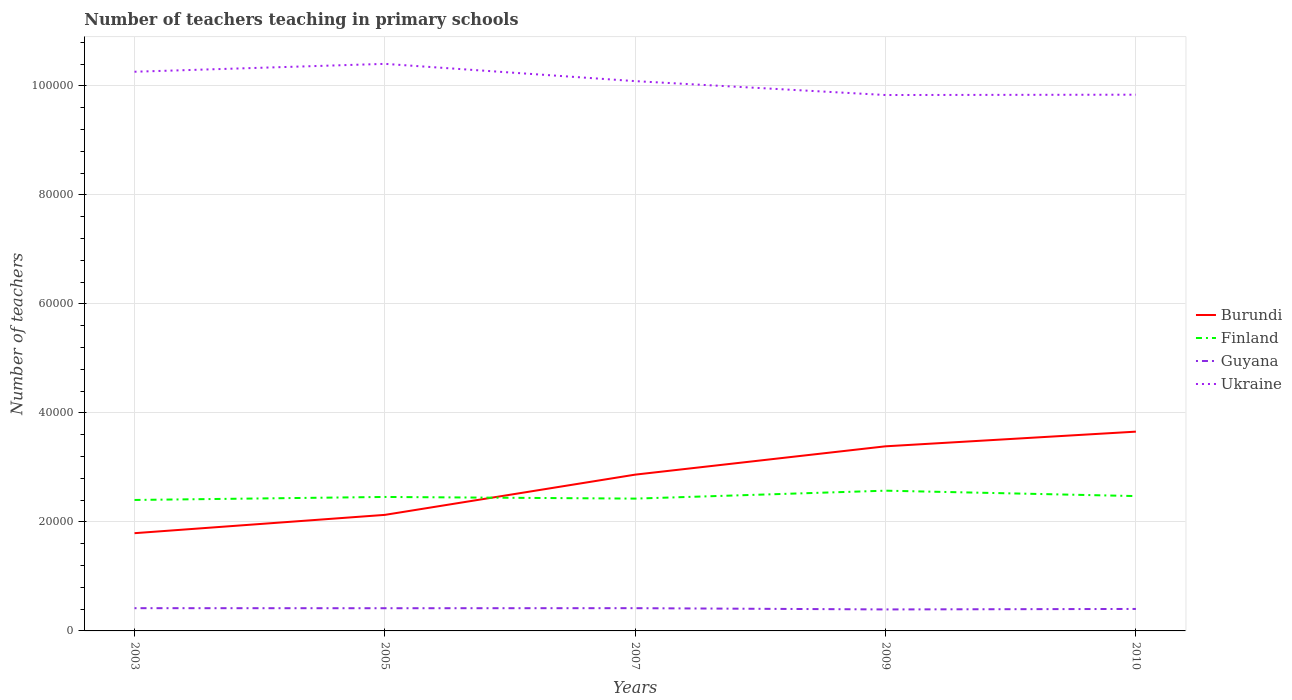How many different coloured lines are there?
Your answer should be compact. 4. Across all years, what is the maximum number of teachers teaching in primary schools in Ukraine?
Your answer should be compact. 9.83e+04. What is the total number of teachers teaching in primary schools in Burundi in the graph?
Ensure brevity in your answer.  -7382. What is the difference between the highest and the second highest number of teachers teaching in primary schools in Finland?
Offer a terse response. 1704. What is the difference between the highest and the lowest number of teachers teaching in primary schools in Burundi?
Make the answer very short. 3. Is the number of teachers teaching in primary schools in Burundi strictly greater than the number of teachers teaching in primary schools in Guyana over the years?
Give a very brief answer. No. How many years are there in the graph?
Provide a succinct answer. 5. What is the difference between two consecutive major ticks on the Y-axis?
Offer a very short reply. 2.00e+04. Are the values on the major ticks of Y-axis written in scientific E-notation?
Offer a very short reply. No. Does the graph contain grids?
Your response must be concise. Yes. How are the legend labels stacked?
Make the answer very short. Vertical. What is the title of the graph?
Offer a very short reply. Number of teachers teaching in primary schools. Does "Sri Lanka" appear as one of the legend labels in the graph?
Your answer should be very brief. No. What is the label or title of the Y-axis?
Provide a short and direct response. Number of teachers. What is the Number of teachers in Burundi in 2003?
Your answer should be compact. 1.79e+04. What is the Number of teachers of Finland in 2003?
Ensure brevity in your answer.  2.40e+04. What is the Number of teachers in Guyana in 2003?
Ensure brevity in your answer.  4174. What is the Number of teachers of Ukraine in 2003?
Make the answer very short. 1.03e+05. What is the Number of teachers of Burundi in 2005?
Ensure brevity in your answer.  2.13e+04. What is the Number of teachers of Finland in 2005?
Ensure brevity in your answer.  2.46e+04. What is the Number of teachers of Guyana in 2005?
Offer a very short reply. 4164. What is the Number of teachers in Ukraine in 2005?
Provide a succinct answer. 1.04e+05. What is the Number of teachers in Burundi in 2007?
Offer a terse response. 2.87e+04. What is the Number of teachers of Finland in 2007?
Make the answer very short. 2.43e+04. What is the Number of teachers in Guyana in 2007?
Your answer should be compact. 4173. What is the Number of teachers of Ukraine in 2007?
Your answer should be compact. 1.01e+05. What is the Number of teachers in Burundi in 2009?
Make the answer very short. 3.39e+04. What is the Number of teachers of Finland in 2009?
Your answer should be compact. 2.57e+04. What is the Number of teachers of Guyana in 2009?
Offer a terse response. 3942. What is the Number of teachers in Ukraine in 2009?
Keep it short and to the point. 9.83e+04. What is the Number of teachers of Burundi in 2010?
Your response must be concise. 3.66e+04. What is the Number of teachers of Finland in 2010?
Your answer should be compact. 2.47e+04. What is the Number of teachers in Guyana in 2010?
Offer a very short reply. 4031. What is the Number of teachers in Ukraine in 2010?
Your response must be concise. 9.84e+04. Across all years, what is the maximum Number of teachers in Burundi?
Give a very brief answer. 3.66e+04. Across all years, what is the maximum Number of teachers of Finland?
Keep it short and to the point. 2.57e+04. Across all years, what is the maximum Number of teachers of Guyana?
Make the answer very short. 4174. Across all years, what is the maximum Number of teachers of Ukraine?
Ensure brevity in your answer.  1.04e+05. Across all years, what is the minimum Number of teachers of Burundi?
Provide a short and direct response. 1.79e+04. Across all years, what is the minimum Number of teachers of Finland?
Offer a very short reply. 2.40e+04. Across all years, what is the minimum Number of teachers of Guyana?
Make the answer very short. 3942. Across all years, what is the minimum Number of teachers in Ukraine?
Ensure brevity in your answer.  9.83e+04. What is the total Number of teachers of Burundi in the graph?
Offer a very short reply. 1.38e+05. What is the total Number of teachers in Finland in the graph?
Your answer should be compact. 1.23e+05. What is the total Number of teachers in Guyana in the graph?
Give a very brief answer. 2.05e+04. What is the total Number of teachers of Ukraine in the graph?
Offer a very short reply. 5.04e+05. What is the difference between the Number of teachers of Burundi in 2003 and that in 2005?
Keep it short and to the point. -3358. What is the difference between the Number of teachers of Finland in 2003 and that in 2005?
Keep it short and to the point. -553. What is the difference between the Number of teachers in Guyana in 2003 and that in 2005?
Provide a succinct answer. 10. What is the difference between the Number of teachers of Ukraine in 2003 and that in 2005?
Your answer should be very brief. -1447. What is the difference between the Number of teachers of Burundi in 2003 and that in 2007?
Ensure brevity in your answer.  -1.07e+04. What is the difference between the Number of teachers in Finland in 2003 and that in 2007?
Your response must be concise. -248. What is the difference between the Number of teachers of Guyana in 2003 and that in 2007?
Keep it short and to the point. 1. What is the difference between the Number of teachers of Ukraine in 2003 and that in 2007?
Offer a terse response. 1722. What is the difference between the Number of teachers of Burundi in 2003 and that in 2009?
Your answer should be compact. -1.59e+04. What is the difference between the Number of teachers in Finland in 2003 and that in 2009?
Provide a succinct answer. -1704. What is the difference between the Number of teachers in Guyana in 2003 and that in 2009?
Offer a terse response. 232. What is the difference between the Number of teachers in Ukraine in 2003 and that in 2009?
Your response must be concise. 4271. What is the difference between the Number of teachers in Burundi in 2003 and that in 2010?
Provide a succinct answer. -1.86e+04. What is the difference between the Number of teachers in Finland in 2003 and that in 2010?
Provide a succinct answer. -712. What is the difference between the Number of teachers of Guyana in 2003 and that in 2010?
Your response must be concise. 143. What is the difference between the Number of teachers of Ukraine in 2003 and that in 2010?
Your answer should be compact. 4210. What is the difference between the Number of teachers of Burundi in 2005 and that in 2007?
Keep it short and to the point. -7382. What is the difference between the Number of teachers in Finland in 2005 and that in 2007?
Keep it short and to the point. 305. What is the difference between the Number of teachers of Guyana in 2005 and that in 2007?
Your answer should be compact. -9. What is the difference between the Number of teachers in Ukraine in 2005 and that in 2007?
Your answer should be compact. 3169. What is the difference between the Number of teachers in Burundi in 2005 and that in 2009?
Your answer should be compact. -1.26e+04. What is the difference between the Number of teachers in Finland in 2005 and that in 2009?
Your answer should be very brief. -1151. What is the difference between the Number of teachers in Guyana in 2005 and that in 2009?
Keep it short and to the point. 222. What is the difference between the Number of teachers of Ukraine in 2005 and that in 2009?
Ensure brevity in your answer.  5718. What is the difference between the Number of teachers in Burundi in 2005 and that in 2010?
Provide a short and direct response. -1.53e+04. What is the difference between the Number of teachers of Finland in 2005 and that in 2010?
Provide a short and direct response. -159. What is the difference between the Number of teachers in Guyana in 2005 and that in 2010?
Offer a very short reply. 133. What is the difference between the Number of teachers of Ukraine in 2005 and that in 2010?
Provide a short and direct response. 5657. What is the difference between the Number of teachers in Burundi in 2007 and that in 2009?
Give a very brief answer. -5196. What is the difference between the Number of teachers in Finland in 2007 and that in 2009?
Make the answer very short. -1456. What is the difference between the Number of teachers in Guyana in 2007 and that in 2009?
Provide a short and direct response. 231. What is the difference between the Number of teachers of Ukraine in 2007 and that in 2009?
Your answer should be very brief. 2549. What is the difference between the Number of teachers in Burundi in 2007 and that in 2010?
Make the answer very short. -7886. What is the difference between the Number of teachers of Finland in 2007 and that in 2010?
Make the answer very short. -464. What is the difference between the Number of teachers in Guyana in 2007 and that in 2010?
Keep it short and to the point. 142. What is the difference between the Number of teachers of Ukraine in 2007 and that in 2010?
Ensure brevity in your answer.  2488. What is the difference between the Number of teachers in Burundi in 2009 and that in 2010?
Your answer should be compact. -2690. What is the difference between the Number of teachers of Finland in 2009 and that in 2010?
Your response must be concise. 992. What is the difference between the Number of teachers of Guyana in 2009 and that in 2010?
Your response must be concise. -89. What is the difference between the Number of teachers of Ukraine in 2009 and that in 2010?
Provide a short and direct response. -61. What is the difference between the Number of teachers in Burundi in 2003 and the Number of teachers in Finland in 2005?
Your answer should be very brief. -6646. What is the difference between the Number of teachers in Burundi in 2003 and the Number of teachers in Guyana in 2005?
Your answer should be compact. 1.38e+04. What is the difference between the Number of teachers of Burundi in 2003 and the Number of teachers of Ukraine in 2005?
Provide a short and direct response. -8.61e+04. What is the difference between the Number of teachers of Finland in 2003 and the Number of teachers of Guyana in 2005?
Offer a terse response. 1.99e+04. What is the difference between the Number of teachers of Finland in 2003 and the Number of teachers of Ukraine in 2005?
Provide a succinct answer. -8.00e+04. What is the difference between the Number of teachers of Guyana in 2003 and the Number of teachers of Ukraine in 2005?
Offer a very short reply. -9.99e+04. What is the difference between the Number of teachers of Burundi in 2003 and the Number of teachers of Finland in 2007?
Your answer should be compact. -6341. What is the difference between the Number of teachers of Burundi in 2003 and the Number of teachers of Guyana in 2007?
Give a very brief answer. 1.38e+04. What is the difference between the Number of teachers in Burundi in 2003 and the Number of teachers in Ukraine in 2007?
Provide a short and direct response. -8.29e+04. What is the difference between the Number of teachers of Finland in 2003 and the Number of teachers of Guyana in 2007?
Your response must be concise. 1.99e+04. What is the difference between the Number of teachers of Finland in 2003 and the Number of teachers of Ukraine in 2007?
Make the answer very short. -7.68e+04. What is the difference between the Number of teachers of Guyana in 2003 and the Number of teachers of Ukraine in 2007?
Your answer should be compact. -9.67e+04. What is the difference between the Number of teachers of Burundi in 2003 and the Number of teachers of Finland in 2009?
Your answer should be very brief. -7797. What is the difference between the Number of teachers in Burundi in 2003 and the Number of teachers in Guyana in 2009?
Your answer should be very brief. 1.40e+04. What is the difference between the Number of teachers in Burundi in 2003 and the Number of teachers in Ukraine in 2009?
Your answer should be very brief. -8.04e+04. What is the difference between the Number of teachers in Finland in 2003 and the Number of teachers in Guyana in 2009?
Give a very brief answer. 2.01e+04. What is the difference between the Number of teachers of Finland in 2003 and the Number of teachers of Ukraine in 2009?
Ensure brevity in your answer.  -7.43e+04. What is the difference between the Number of teachers of Guyana in 2003 and the Number of teachers of Ukraine in 2009?
Offer a very short reply. -9.41e+04. What is the difference between the Number of teachers of Burundi in 2003 and the Number of teachers of Finland in 2010?
Offer a terse response. -6805. What is the difference between the Number of teachers in Burundi in 2003 and the Number of teachers in Guyana in 2010?
Keep it short and to the point. 1.39e+04. What is the difference between the Number of teachers of Burundi in 2003 and the Number of teachers of Ukraine in 2010?
Provide a succinct answer. -8.04e+04. What is the difference between the Number of teachers in Finland in 2003 and the Number of teachers in Guyana in 2010?
Ensure brevity in your answer.  2.00e+04. What is the difference between the Number of teachers in Finland in 2003 and the Number of teachers in Ukraine in 2010?
Your answer should be compact. -7.43e+04. What is the difference between the Number of teachers of Guyana in 2003 and the Number of teachers of Ukraine in 2010?
Provide a succinct answer. -9.42e+04. What is the difference between the Number of teachers in Burundi in 2005 and the Number of teachers in Finland in 2007?
Offer a terse response. -2983. What is the difference between the Number of teachers in Burundi in 2005 and the Number of teachers in Guyana in 2007?
Provide a succinct answer. 1.71e+04. What is the difference between the Number of teachers in Burundi in 2005 and the Number of teachers in Ukraine in 2007?
Provide a short and direct response. -7.96e+04. What is the difference between the Number of teachers in Finland in 2005 and the Number of teachers in Guyana in 2007?
Give a very brief answer. 2.04e+04. What is the difference between the Number of teachers in Finland in 2005 and the Number of teachers in Ukraine in 2007?
Your response must be concise. -7.63e+04. What is the difference between the Number of teachers of Guyana in 2005 and the Number of teachers of Ukraine in 2007?
Your response must be concise. -9.67e+04. What is the difference between the Number of teachers in Burundi in 2005 and the Number of teachers in Finland in 2009?
Provide a short and direct response. -4439. What is the difference between the Number of teachers of Burundi in 2005 and the Number of teachers of Guyana in 2009?
Your response must be concise. 1.73e+04. What is the difference between the Number of teachers of Burundi in 2005 and the Number of teachers of Ukraine in 2009?
Your response must be concise. -7.70e+04. What is the difference between the Number of teachers in Finland in 2005 and the Number of teachers in Guyana in 2009?
Give a very brief answer. 2.06e+04. What is the difference between the Number of teachers in Finland in 2005 and the Number of teachers in Ukraine in 2009?
Give a very brief answer. -7.37e+04. What is the difference between the Number of teachers in Guyana in 2005 and the Number of teachers in Ukraine in 2009?
Your response must be concise. -9.41e+04. What is the difference between the Number of teachers in Burundi in 2005 and the Number of teachers in Finland in 2010?
Ensure brevity in your answer.  -3447. What is the difference between the Number of teachers in Burundi in 2005 and the Number of teachers in Guyana in 2010?
Ensure brevity in your answer.  1.73e+04. What is the difference between the Number of teachers of Burundi in 2005 and the Number of teachers of Ukraine in 2010?
Ensure brevity in your answer.  -7.71e+04. What is the difference between the Number of teachers in Finland in 2005 and the Number of teachers in Guyana in 2010?
Make the answer very short. 2.05e+04. What is the difference between the Number of teachers of Finland in 2005 and the Number of teachers of Ukraine in 2010?
Ensure brevity in your answer.  -7.38e+04. What is the difference between the Number of teachers in Guyana in 2005 and the Number of teachers in Ukraine in 2010?
Your answer should be compact. -9.42e+04. What is the difference between the Number of teachers of Burundi in 2007 and the Number of teachers of Finland in 2009?
Give a very brief answer. 2943. What is the difference between the Number of teachers in Burundi in 2007 and the Number of teachers in Guyana in 2009?
Make the answer very short. 2.47e+04. What is the difference between the Number of teachers in Burundi in 2007 and the Number of teachers in Ukraine in 2009?
Offer a terse response. -6.96e+04. What is the difference between the Number of teachers in Finland in 2007 and the Number of teachers in Guyana in 2009?
Offer a terse response. 2.03e+04. What is the difference between the Number of teachers in Finland in 2007 and the Number of teachers in Ukraine in 2009?
Offer a very short reply. -7.40e+04. What is the difference between the Number of teachers in Guyana in 2007 and the Number of teachers in Ukraine in 2009?
Offer a very short reply. -9.41e+04. What is the difference between the Number of teachers in Burundi in 2007 and the Number of teachers in Finland in 2010?
Give a very brief answer. 3935. What is the difference between the Number of teachers of Burundi in 2007 and the Number of teachers of Guyana in 2010?
Provide a short and direct response. 2.46e+04. What is the difference between the Number of teachers in Burundi in 2007 and the Number of teachers in Ukraine in 2010?
Make the answer very short. -6.97e+04. What is the difference between the Number of teachers in Finland in 2007 and the Number of teachers in Guyana in 2010?
Your answer should be compact. 2.02e+04. What is the difference between the Number of teachers in Finland in 2007 and the Number of teachers in Ukraine in 2010?
Keep it short and to the point. -7.41e+04. What is the difference between the Number of teachers in Guyana in 2007 and the Number of teachers in Ukraine in 2010?
Your response must be concise. -9.42e+04. What is the difference between the Number of teachers in Burundi in 2009 and the Number of teachers in Finland in 2010?
Your response must be concise. 9131. What is the difference between the Number of teachers in Burundi in 2009 and the Number of teachers in Guyana in 2010?
Your response must be concise. 2.98e+04. What is the difference between the Number of teachers of Burundi in 2009 and the Number of teachers of Ukraine in 2010?
Your answer should be compact. -6.45e+04. What is the difference between the Number of teachers in Finland in 2009 and the Number of teachers in Guyana in 2010?
Offer a terse response. 2.17e+04. What is the difference between the Number of teachers of Finland in 2009 and the Number of teachers of Ukraine in 2010?
Provide a succinct answer. -7.26e+04. What is the difference between the Number of teachers of Guyana in 2009 and the Number of teachers of Ukraine in 2010?
Ensure brevity in your answer.  -9.44e+04. What is the average Number of teachers in Burundi per year?
Keep it short and to the point. 2.77e+04. What is the average Number of teachers in Finland per year?
Your answer should be compact. 2.47e+04. What is the average Number of teachers in Guyana per year?
Offer a very short reply. 4096.8. What is the average Number of teachers in Ukraine per year?
Provide a short and direct response. 1.01e+05. In the year 2003, what is the difference between the Number of teachers of Burundi and Number of teachers of Finland?
Your answer should be very brief. -6093. In the year 2003, what is the difference between the Number of teachers of Burundi and Number of teachers of Guyana?
Your answer should be very brief. 1.38e+04. In the year 2003, what is the difference between the Number of teachers of Burundi and Number of teachers of Ukraine?
Your answer should be very brief. -8.46e+04. In the year 2003, what is the difference between the Number of teachers in Finland and Number of teachers in Guyana?
Provide a short and direct response. 1.98e+04. In the year 2003, what is the difference between the Number of teachers in Finland and Number of teachers in Ukraine?
Your answer should be compact. -7.86e+04. In the year 2003, what is the difference between the Number of teachers in Guyana and Number of teachers in Ukraine?
Give a very brief answer. -9.84e+04. In the year 2005, what is the difference between the Number of teachers in Burundi and Number of teachers in Finland?
Give a very brief answer. -3288. In the year 2005, what is the difference between the Number of teachers of Burundi and Number of teachers of Guyana?
Ensure brevity in your answer.  1.71e+04. In the year 2005, what is the difference between the Number of teachers in Burundi and Number of teachers in Ukraine?
Your response must be concise. -8.27e+04. In the year 2005, what is the difference between the Number of teachers of Finland and Number of teachers of Guyana?
Keep it short and to the point. 2.04e+04. In the year 2005, what is the difference between the Number of teachers in Finland and Number of teachers in Ukraine?
Provide a succinct answer. -7.95e+04. In the year 2005, what is the difference between the Number of teachers in Guyana and Number of teachers in Ukraine?
Provide a succinct answer. -9.99e+04. In the year 2007, what is the difference between the Number of teachers in Burundi and Number of teachers in Finland?
Offer a terse response. 4399. In the year 2007, what is the difference between the Number of teachers in Burundi and Number of teachers in Guyana?
Offer a terse response. 2.45e+04. In the year 2007, what is the difference between the Number of teachers of Burundi and Number of teachers of Ukraine?
Offer a terse response. -7.22e+04. In the year 2007, what is the difference between the Number of teachers of Finland and Number of teachers of Guyana?
Provide a short and direct response. 2.01e+04. In the year 2007, what is the difference between the Number of teachers of Finland and Number of teachers of Ukraine?
Provide a succinct answer. -7.66e+04. In the year 2007, what is the difference between the Number of teachers of Guyana and Number of teachers of Ukraine?
Offer a very short reply. -9.67e+04. In the year 2009, what is the difference between the Number of teachers in Burundi and Number of teachers in Finland?
Make the answer very short. 8139. In the year 2009, what is the difference between the Number of teachers of Burundi and Number of teachers of Guyana?
Give a very brief answer. 2.99e+04. In the year 2009, what is the difference between the Number of teachers in Burundi and Number of teachers in Ukraine?
Provide a succinct answer. -6.44e+04. In the year 2009, what is the difference between the Number of teachers in Finland and Number of teachers in Guyana?
Your answer should be compact. 2.18e+04. In the year 2009, what is the difference between the Number of teachers of Finland and Number of teachers of Ukraine?
Make the answer very short. -7.26e+04. In the year 2009, what is the difference between the Number of teachers in Guyana and Number of teachers in Ukraine?
Make the answer very short. -9.44e+04. In the year 2010, what is the difference between the Number of teachers of Burundi and Number of teachers of Finland?
Your response must be concise. 1.18e+04. In the year 2010, what is the difference between the Number of teachers of Burundi and Number of teachers of Guyana?
Your answer should be compact. 3.25e+04. In the year 2010, what is the difference between the Number of teachers of Burundi and Number of teachers of Ukraine?
Make the answer very short. -6.18e+04. In the year 2010, what is the difference between the Number of teachers of Finland and Number of teachers of Guyana?
Keep it short and to the point. 2.07e+04. In the year 2010, what is the difference between the Number of teachers of Finland and Number of teachers of Ukraine?
Make the answer very short. -7.36e+04. In the year 2010, what is the difference between the Number of teachers in Guyana and Number of teachers in Ukraine?
Provide a succinct answer. -9.43e+04. What is the ratio of the Number of teachers in Burundi in 2003 to that in 2005?
Make the answer very short. 0.84. What is the ratio of the Number of teachers of Finland in 2003 to that in 2005?
Provide a succinct answer. 0.98. What is the ratio of the Number of teachers in Guyana in 2003 to that in 2005?
Provide a succinct answer. 1. What is the ratio of the Number of teachers in Ukraine in 2003 to that in 2005?
Your answer should be very brief. 0.99. What is the ratio of the Number of teachers in Burundi in 2003 to that in 2007?
Offer a terse response. 0.63. What is the ratio of the Number of teachers of Guyana in 2003 to that in 2007?
Keep it short and to the point. 1. What is the ratio of the Number of teachers of Ukraine in 2003 to that in 2007?
Keep it short and to the point. 1.02. What is the ratio of the Number of teachers in Burundi in 2003 to that in 2009?
Ensure brevity in your answer.  0.53. What is the ratio of the Number of teachers of Finland in 2003 to that in 2009?
Provide a succinct answer. 0.93. What is the ratio of the Number of teachers of Guyana in 2003 to that in 2009?
Offer a terse response. 1.06. What is the ratio of the Number of teachers of Ukraine in 2003 to that in 2009?
Provide a succinct answer. 1.04. What is the ratio of the Number of teachers of Burundi in 2003 to that in 2010?
Ensure brevity in your answer.  0.49. What is the ratio of the Number of teachers in Finland in 2003 to that in 2010?
Your answer should be very brief. 0.97. What is the ratio of the Number of teachers in Guyana in 2003 to that in 2010?
Provide a short and direct response. 1.04. What is the ratio of the Number of teachers of Ukraine in 2003 to that in 2010?
Your response must be concise. 1.04. What is the ratio of the Number of teachers in Burundi in 2005 to that in 2007?
Your answer should be very brief. 0.74. What is the ratio of the Number of teachers of Finland in 2005 to that in 2007?
Give a very brief answer. 1.01. What is the ratio of the Number of teachers in Guyana in 2005 to that in 2007?
Offer a very short reply. 1. What is the ratio of the Number of teachers in Ukraine in 2005 to that in 2007?
Your answer should be compact. 1.03. What is the ratio of the Number of teachers of Burundi in 2005 to that in 2009?
Make the answer very short. 0.63. What is the ratio of the Number of teachers in Finland in 2005 to that in 2009?
Give a very brief answer. 0.96. What is the ratio of the Number of teachers in Guyana in 2005 to that in 2009?
Provide a short and direct response. 1.06. What is the ratio of the Number of teachers of Ukraine in 2005 to that in 2009?
Ensure brevity in your answer.  1.06. What is the ratio of the Number of teachers in Burundi in 2005 to that in 2010?
Ensure brevity in your answer.  0.58. What is the ratio of the Number of teachers of Finland in 2005 to that in 2010?
Your response must be concise. 0.99. What is the ratio of the Number of teachers in Guyana in 2005 to that in 2010?
Your answer should be compact. 1.03. What is the ratio of the Number of teachers in Ukraine in 2005 to that in 2010?
Offer a terse response. 1.06. What is the ratio of the Number of teachers of Burundi in 2007 to that in 2009?
Your answer should be very brief. 0.85. What is the ratio of the Number of teachers in Finland in 2007 to that in 2009?
Your answer should be very brief. 0.94. What is the ratio of the Number of teachers of Guyana in 2007 to that in 2009?
Provide a succinct answer. 1.06. What is the ratio of the Number of teachers of Ukraine in 2007 to that in 2009?
Offer a very short reply. 1.03. What is the ratio of the Number of teachers in Burundi in 2007 to that in 2010?
Give a very brief answer. 0.78. What is the ratio of the Number of teachers in Finland in 2007 to that in 2010?
Provide a short and direct response. 0.98. What is the ratio of the Number of teachers in Guyana in 2007 to that in 2010?
Make the answer very short. 1.04. What is the ratio of the Number of teachers of Ukraine in 2007 to that in 2010?
Offer a very short reply. 1.03. What is the ratio of the Number of teachers of Burundi in 2009 to that in 2010?
Offer a very short reply. 0.93. What is the ratio of the Number of teachers in Finland in 2009 to that in 2010?
Provide a succinct answer. 1.04. What is the ratio of the Number of teachers in Guyana in 2009 to that in 2010?
Ensure brevity in your answer.  0.98. What is the difference between the highest and the second highest Number of teachers of Burundi?
Your answer should be very brief. 2690. What is the difference between the highest and the second highest Number of teachers of Finland?
Your answer should be very brief. 992. What is the difference between the highest and the second highest Number of teachers in Guyana?
Provide a short and direct response. 1. What is the difference between the highest and the second highest Number of teachers of Ukraine?
Make the answer very short. 1447. What is the difference between the highest and the lowest Number of teachers in Burundi?
Your answer should be compact. 1.86e+04. What is the difference between the highest and the lowest Number of teachers in Finland?
Your answer should be very brief. 1704. What is the difference between the highest and the lowest Number of teachers of Guyana?
Keep it short and to the point. 232. What is the difference between the highest and the lowest Number of teachers in Ukraine?
Provide a short and direct response. 5718. 